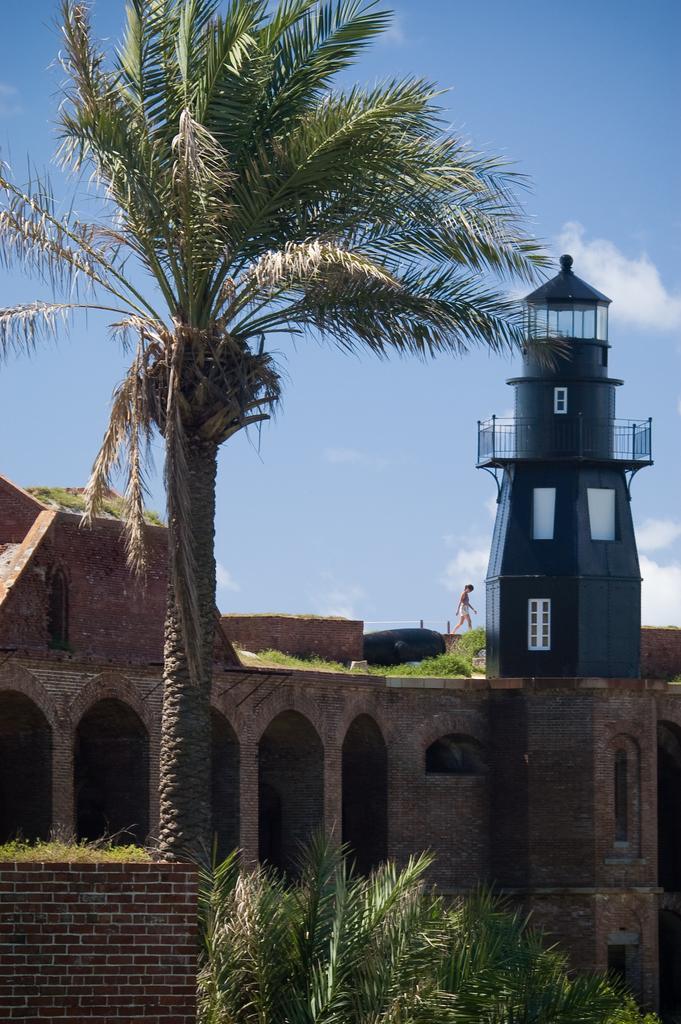What type of structure is visible in the image? There is a building and a tower in the image. What other natural elements can be seen in the image? There are trees in the image. Can you describe the person in the image? There is a person walking in the image. What are the poles used for in the image? The purpose of the poles is not specified in the image. What is visible in the sky at the top of the image? There are clouds in the sky at the top of the image. Where is the market located in the image? There is no market present in the image. What type of pain is the person in the image experiencing? There is no indication of pain or discomfort for the person in the image. 